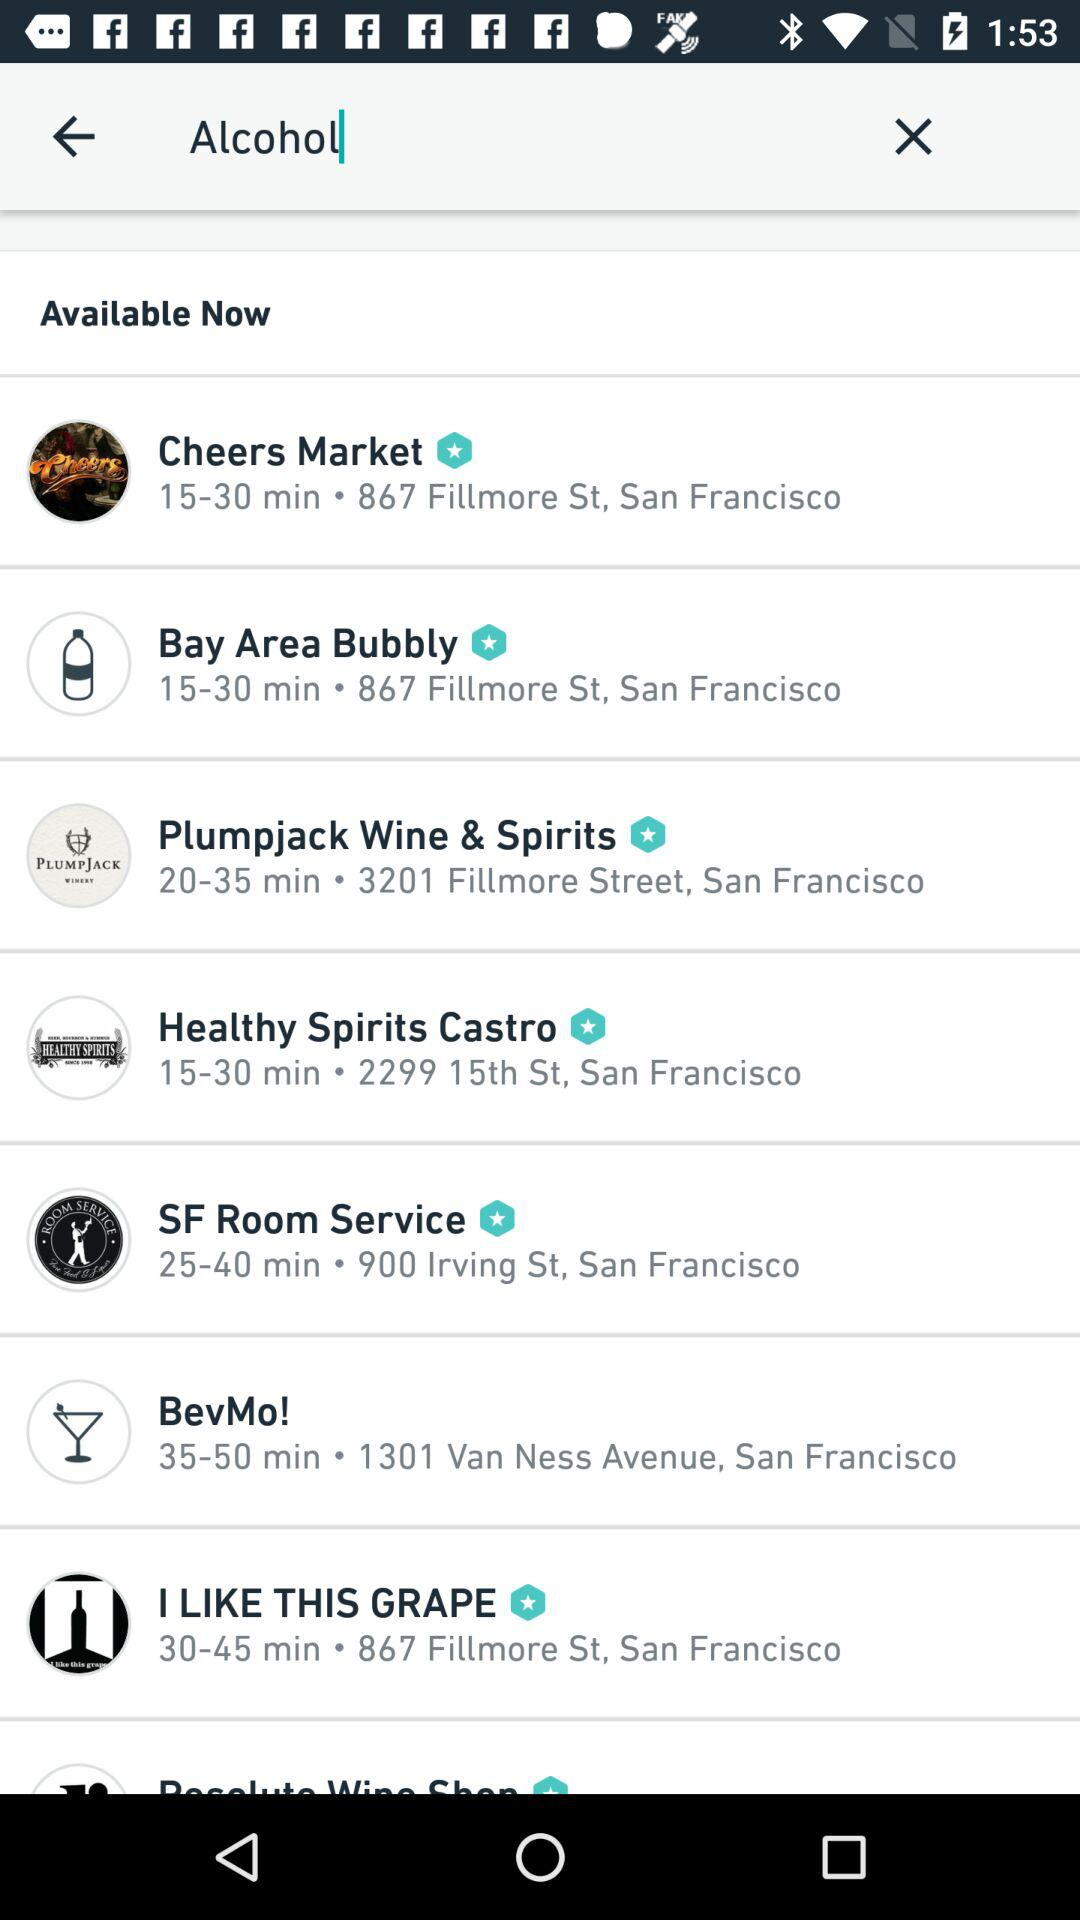What is the location for "I LIKE THIS GRAPE"? The location for "I LIKE THIS GRAPE" is 867 Fillmore St., San Francisco. 